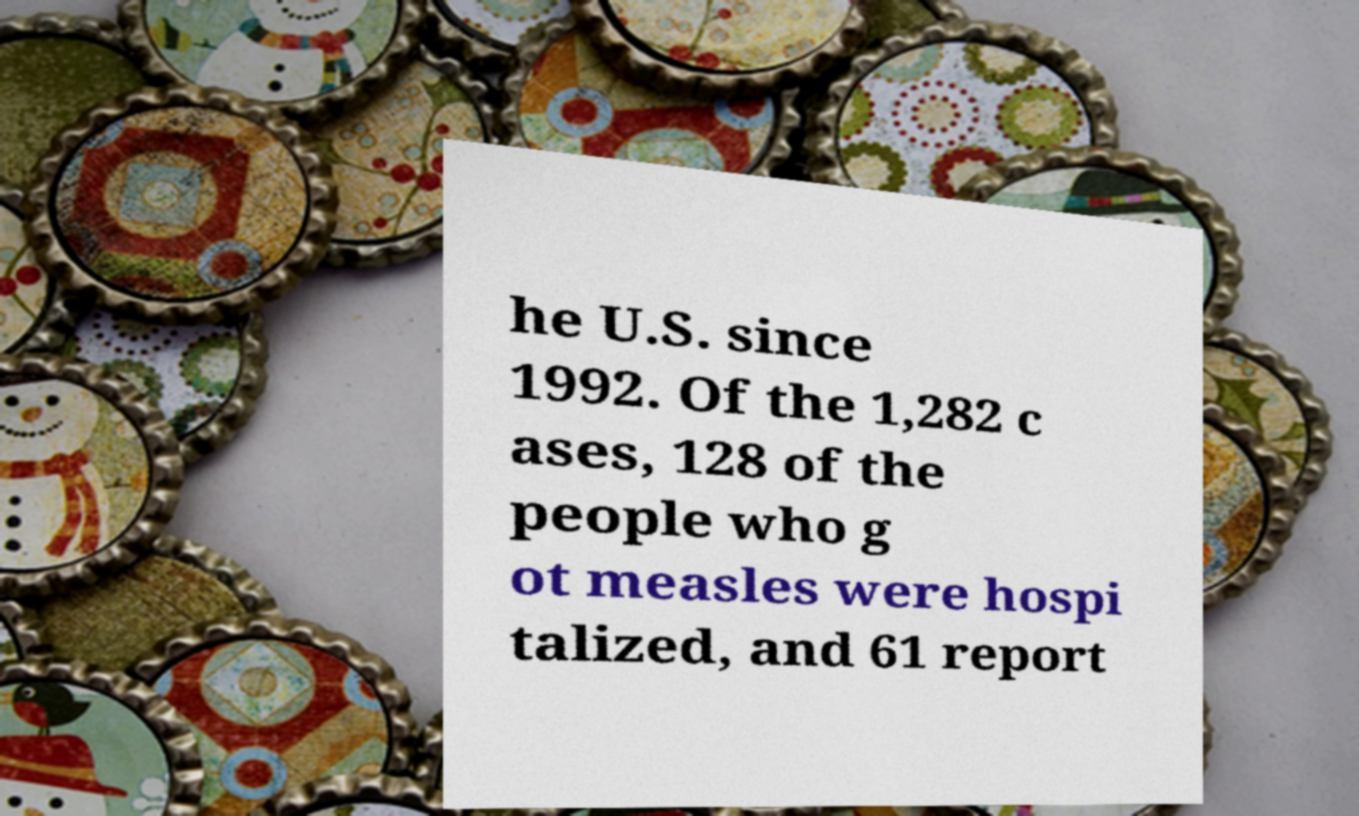Could you extract and type out the text from this image? he U.S. since 1992. Of the 1,282 c ases, 128 of the people who g ot measles were hospi talized, and 61 report 